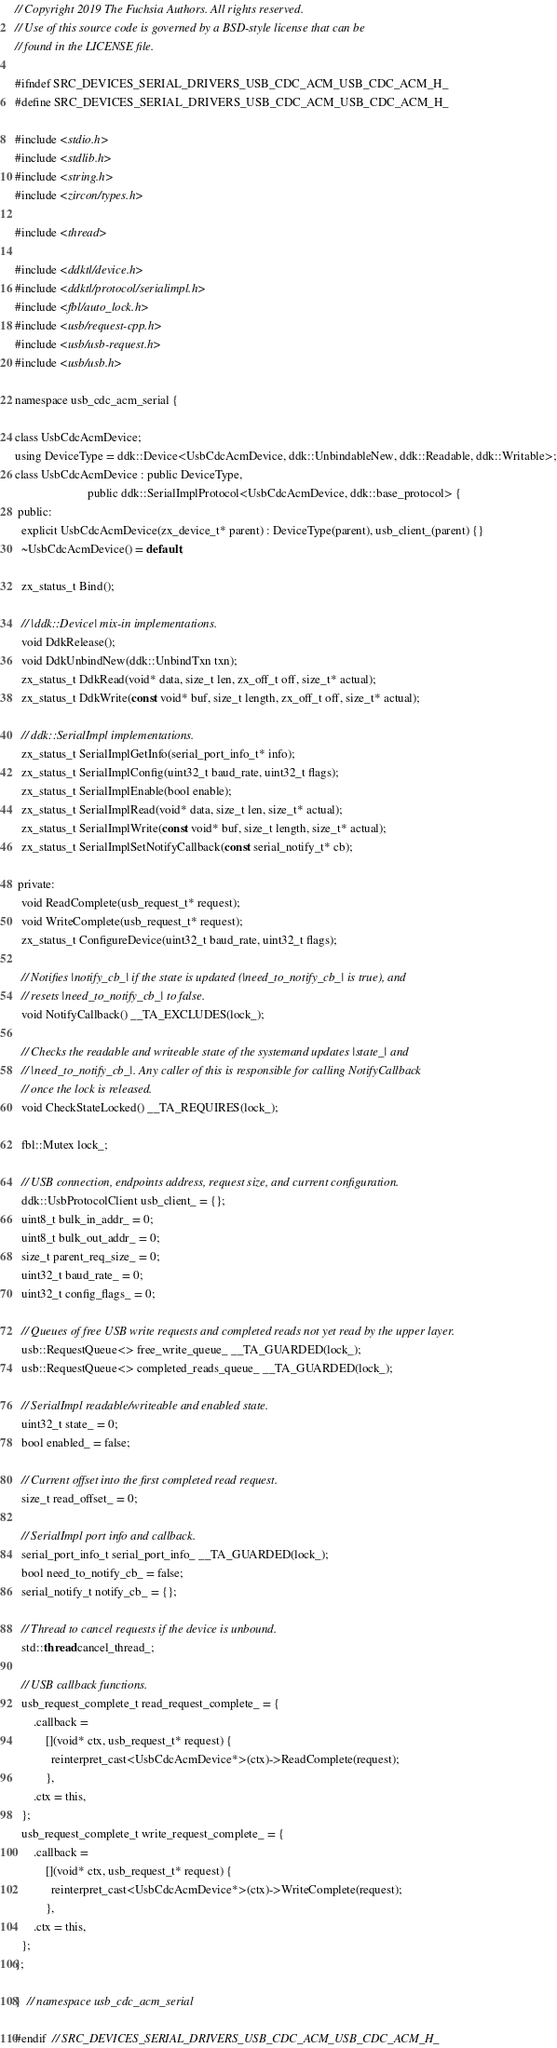Convert code to text. <code><loc_0><loc_0><loc_500><loc_500><_C_>// Copyright 2019 The Fuchsia Authors. All rights reserved.
// Use of this source code is governed by a BSD-style license that can be
// found in the LICENSE file.

#ifndef SRC_DEVICES_SERIAL_DRIVERS_USB_CDC_ACM_USB_CDC_ACM_H_
#define SRC_DEVICES_SERIAL_DRIVERS_USB_CDC_ACM_USB_CDC_ACM_H_

#include <stdio.h>
#include <stdlib.h>
#include <string.h>
#include <zircon/types.h>

#include <thread>

#include <ddktl/device.h>
#include <ddktl/protocol/serialimpl.h>
#include <fbl/auto_lock.h>
#include <usb/request-cpp.h>
#include <usb/usb-request.h>
#include <usb/usb.h>

namespace usb_cdc_acm_serial {

class UsbCdcAcmDevice;
using DeviceType = ddk::Device<UsbCdcAcmDevice, ddk::UnbindableNew, ddk::Readable, ddk::Writable>;
class UsbCdcAcmDevice : public DeviceType,
                        public ddk::SerialImplProtocol<UsbCdcAcmDevice, ddk::base_protocol> {
 public:
  explicit UsbCdcAcmDevice(zx_device_t* parent) : DeviceType(parent), usb_client_(parent) {}
  ~UsbCdcAcmDevice() = default;

  zx_status_t Bind();

  // |ddk::Device| mix-in implementations.
  void DdkRelease();
  void DdkUnbindNew(ddk::UnbindTxn txn);
  zx_status_t DdkRead(void* data, size_t len, zx_off_t off, size_t* actual);
  zx_status_t DdkWrite(const void* buf, size_t length, zx_off_t off, size_t* actual);

  // ddk::SerialImpl implementations.
  zx_status_t SerialImplGetInfo(serial_port_info_t* info);
  zx_status_t SerialImplConfig(uint32_t baud_rate, uint32_t flags);
  zx_status_t SerialImplEnable(bool enable);
  zx_status_t SerialImplRead(void* data, size_t len, size_t* actual);
  zx_status_t SerialImplWrite(const void* buf, size_t length, size_t* actual);
  zx_status_t SerialImplSetNotifyCallback(const serial_notify_t* cb);

 private:
  void ReadComplete(usb_request_t* request);
  void WriteComplete(usb_request_t* request);
  zx_status_t ConfigureDevice(uint32_t baud_rate, uint32_t flags);

  // Notifies |notify_cb_| if the state is updated (|need_to_notify_cb_| is true), and
  // resets |need_to_notify_cb_| to false.
  void NotifyCallback() __TA_EXCLUDES(lock_);

  // Checks the readable and writeable state of the systemand updates |state_| and
  // |need_to_notify_cb_|. Any caller of this is responsible for calling NotifyCallback
  // once the lock is released.
  void CheckStateLocked() __TA_REQUIRES(lock_);

  fbl::Mutex lock_;

  // USB connection, endpoints address, request size, and current configuration.
  ddk::UsbProtocolClient usb_client_ = {};
  uint8_t bulk_in_addr_ = 0;
  uint8_t bulk_out_addr_ = 0;
  size_t parent_req_size_ = 0;
  uint32_t baud_rate_ = 0;
  uint32_t config_flags_ = 0;

  // Queues of free USB write requests and completed reads not yet read by the upper layer.
  usb::RequestQueue<> free_write_queue_ __TA_GUARDED(lock_);
  usb::RequestQueue<> completed_reads_queue_ __TA_GUARDED(lock_);

  // SerialImpl readable/writeable and enabled state.
  uint32_t state_ = 0;
  bool enabled_ = false;

  // Current offset into the first completed read request.
  size_t read_offset_ = 0;

  // SerialImpl port info and callback.
  serial_port_info_t serial_port_info_ __TA_GUARDED(lock_);
  bool need_to_notify_cb_ = false;
  serial_notify_t notify_cb_ = {};

  // Thread to cancel requests if the device is unbound.
  std::thread cancel_thread_;

  // USB callback functions.
  usb_request_complete_t read_request_complete_ = {
      .callback =
          [](void* ctx, usb_request_t* request) {
            reinterpret_cast<UsbCdcAcmDevice*>(ctx)->ReadComplete(request);
          },
      .ctx = this,
  };
  usb_request_complete_t write_request_complete_ = {
      .callback =
          [](void* ctx, usb_request_t* request) {
            reinterpret_cast<UsbCdcAcmDevice*>(ctx)->WriteComplete(request);
          },
      .ctx = this,
  };
};

}  // namespace usb_cdc_acm_serial

#endif  // SRC_DEVICES_SERIAL_DRIVERS_USB_CDC_ACM_USB_CDC_ACM_H_
</code> 